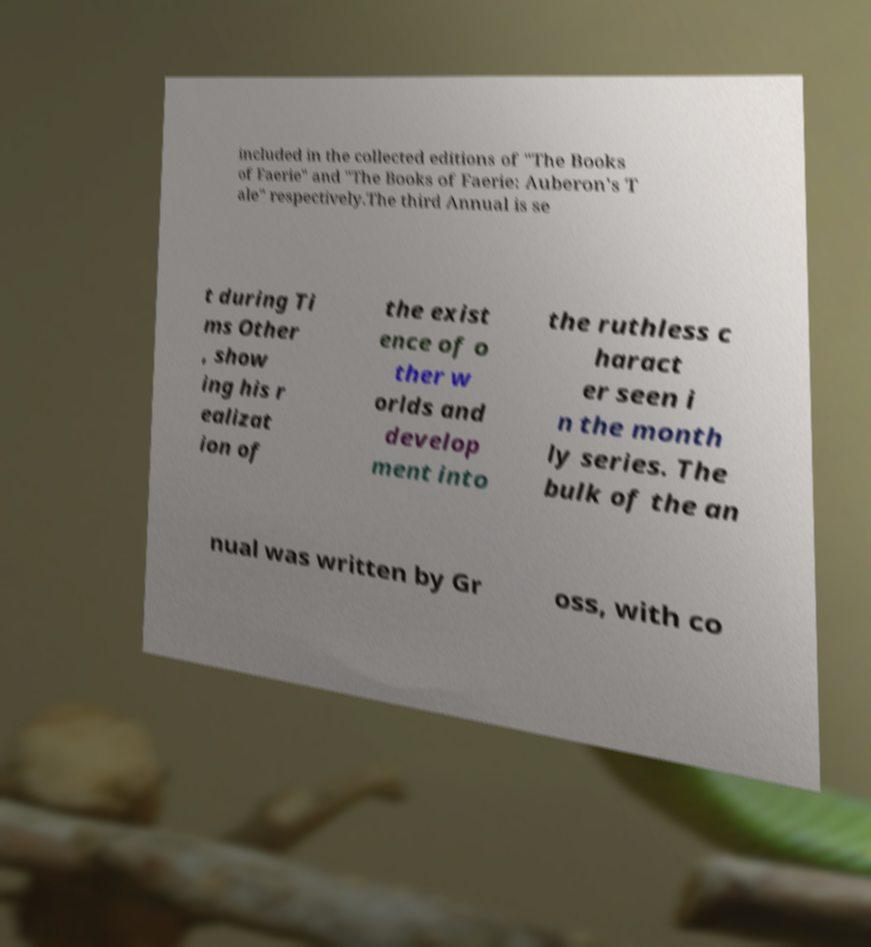Please identify and transcribe the text found in this image. included in the collected editions of "The Books of Faerie" and "The Books of Faerie: Auberon's T ale" respectively.The third Annual is se t during Ti ms Other , show ing his r ealizat ion of the exist ence of o ther w orlds and develop ment into the ruthless c haract er seen i n the month ly series. The bulk of the an nual was written by Gr oss, with co 